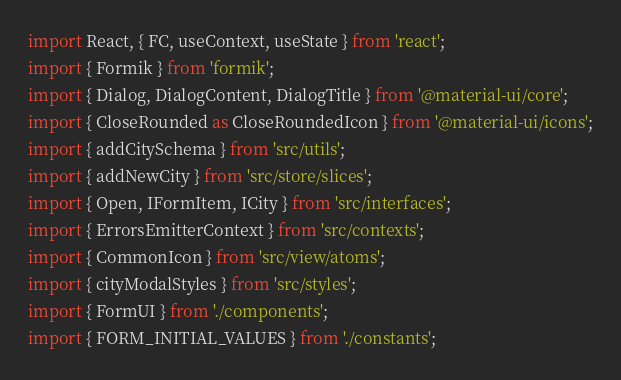<code> <loc_0><loc_0><loc_500><loc_500><_TypeScript_>import React, { FC, useContext, useState } from 'react';
import { Formik } from 'formik';
import { Dialog, DialogContent, DialogTitle } from '@material-ui/core';
import { CloseRounded as CloseRoundedIcon } from '@material-ui/icons';
import { addCitySchema } from 'src/utils';
import { addNewCity } from 'src/store/slices';
import { Open, IFormItem, ICity } from 'src/interfaces';
import { ErrorsEmitterContext } from 'src/contexts';
import { CommonIcon } from 'src/view/atoms';
import { cityModalStyles } from 'src/styles';
import { FormUI } from './components';
import { FORM_INITIAL_VALUES } from './constants';</code> 